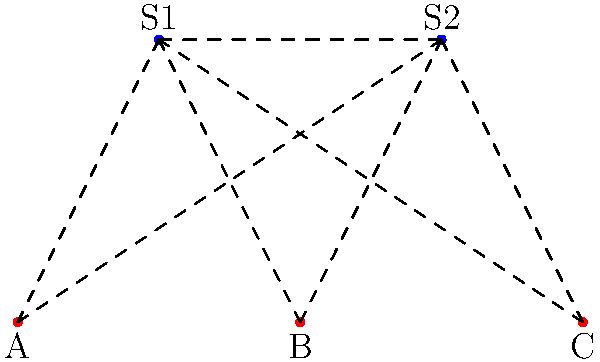In the satellite network topology shown above, there are three ground stations (A, B, C) and two orbital satellites (S1, S2). Assuming all possible connections between ground stations and satellites are active, what is the minimum number of link failures required to completely isolate one ground station from the rest of the network? To solve this problem, we need to analyze the network topology and consider the possible ways to isolate a ground station. Let's approach this step-by-step:

1. Each ground station is connected to both satellites:
   - A is connected to S1 and S2
   - B is connected to S1 and S2
   - C is connected to S1 and S2

2. The two satellites (S1 and S2) are also connected to each other.

3. To isolate a ground station, we need to cut all its connections to the network. This means we need to remove its links to both satellites.

4. For any ground station:
   - Removing the link to S1 cuts one path
   - Removing the link to S2 cuts the second path

5. After removing these two links, the ground station has no direct connection to any other node in the network.

6. The satellite-to-satellite link doesn't affect this minimum number, as it doesn't provide an additional path for the isolated ground station.

Therefore, the minimum number of link failures required to completely isolate one ground station is 2. This is true for any of the ground stations A, B, or C.
Answer: 2 link failures 